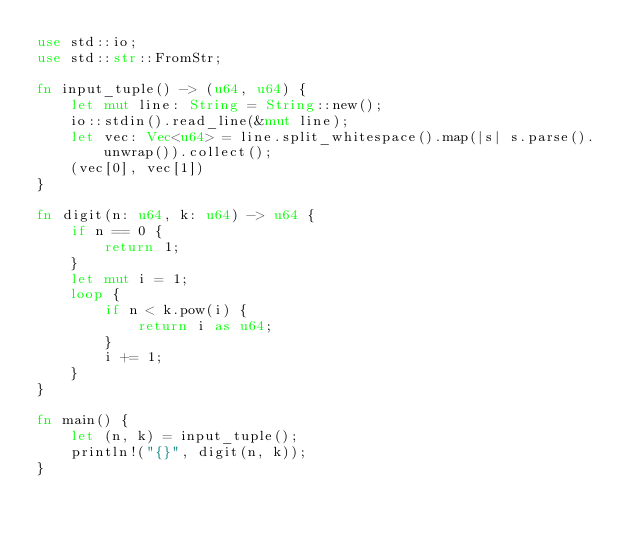Convert code to text. <code><loc_0><loc_0><loc_500><loc_500><_Rust_>use std::io;
use std::str::FromStr;

fn input_tuple() -> (u64, u64) {
    let mut line: String = String::new();
    io::stdin().read_line(&mut line);
    let vec: Vec<u64> = line.split_whitespace().map(|s| s.parse().unwrap()).collect();
    (vec[0], vec[1])
}

fn digit(n: u64, k: u64) -> u64 {
    if n == 0 {
        return 1;
    }
    let mut i = 1;
    loop {
        if n < k.pow(i) {
            return i as u64;
        }
        i += 1;
    }
}

fn main() {
    let (n, k) = input_tuple();
    println!("{}", digit(n, k));
}
</code> 